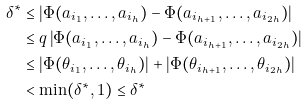Convert formula to latex. <formula><loc_0><loc_0><loc_500><loc_500>\delta ^ { * } & \leq | \Phi ( a _ { i _ { 1 } } , \dots , a _ { i _ { h } } ) - \Phi ( a _ { i _ { h + 1 } } , \dots , a _ { i _ { 2 h } } ) | \\ & \leq q \left | \Phi ( a _ { i _ { 1 } } , \dots , a _ { i _ { h } } ) - \Phi ( a _ { i _ { h + 1 } } , \dots , a _ { i _ { 2 h } } ) \right | \\ & \leq \left | \Phi ( \theta _ { i _ { 1 } } , \dots , \theta _ { i _ { h } } ) \right | + \left | \Phi ( \theta _ { i _ { h + 1 } } , \dots , \theta _ { i _ { 2 h } } ) \right | \\ & < \min ( \delta ^ { * } , 1 ) \leq \delta ^ { * }</formula> 